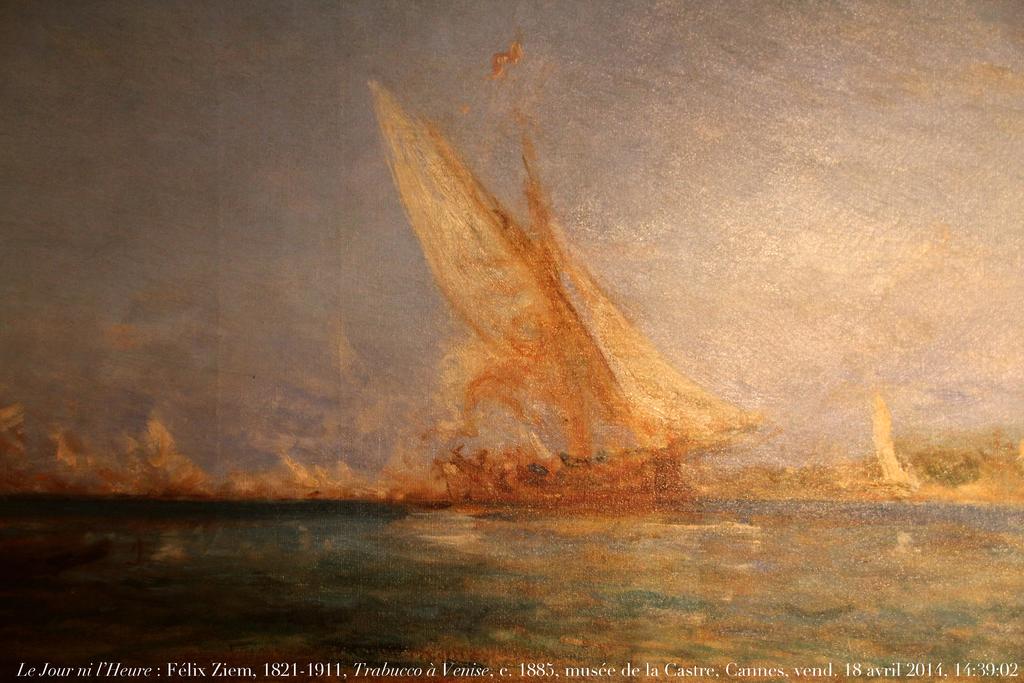When was the original piece painted?
Provide a short and direct response. 1885. Who painted the image?
Give a very brief answer. Felix ziem. 